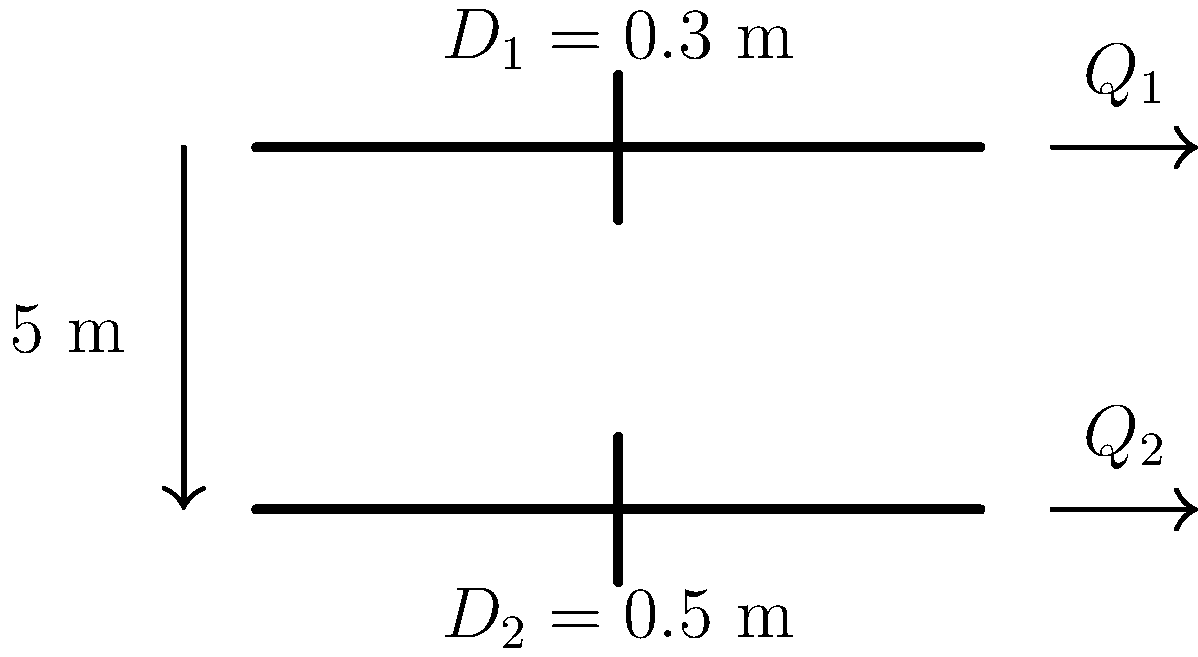As part of a flood protection system for your small business district, you're reviewing plans for a drainage network. The system includes two parallel pipes at different elevations, as shown in the diagram. The upper pipe has a diameter $D_1 = 0.3$ m, while the lower pipe has a diameter $D_2 = 0.5$ m. The pipes are separated by a vertical distance of 5 m. If the flow rate in the upper pipe is $Q_1 = 0.5$ m³/s, what is the flow rate $Q_2$ in the lower pipe to ensure equal flow velocities in both pipes? To solve this problem, we'll follow these steps:

1) First, recall that the flow rate $Q$ is related to the flow velocity $v$ and the cross-sectional area $A$ of the pipe by the equation:

   $Q = vA$

2) The cross-sectional area of a circular pipe is given by:

   $A = \frac{\pi D^2}{4}$

3) For the upper pipe (pipe 1):
   $Q_1 = v_1A_1 = v_1 \cdot \frac{\pi D_1^2}{4}$

4) For the lower pipe (pipe 2):
   $Q_2 = v_2A_2 = v_2 \cdot \frac{\pi D_2^2}{4}$

5) We want the velocities to be equal, so $v_1 = v_2 = v$. Therefore:

   $Q_1 = v \cdot \frac{\pi D_1^2}{4}$ and $Q_2 = v \cdot \frac{\pi D_2^2}{4}$

6) Dividing these equations:

   $\frac{Q_2}{Q_1} = \frac{D_2^2}{D_1^2}$

7) Rearranging to solve for $Q_2$:

   $Q_2 = Q_1 \cdot \frac{D_2^2}{D_1^2}$

8) Substituting the known values:

   $Q_2 = 0.5 \text{ m³/s} \cdot \frac{(0.5 \text{ m})^2}{(0.3 \text{ m})^2}$

9) Calculating:

   $Q_2 = 0.5 \cdot \frac{0.25}{0.09} = 0.5 \cdot 2.778 = 1.389 \text{ m³/s}$

Therefore, the flow rate in the lower pipe should be approximately 1.389 m³/s to ensure equal flow velocities in both pipes.
Answer: $1.389 \text{ m³/s}$ 